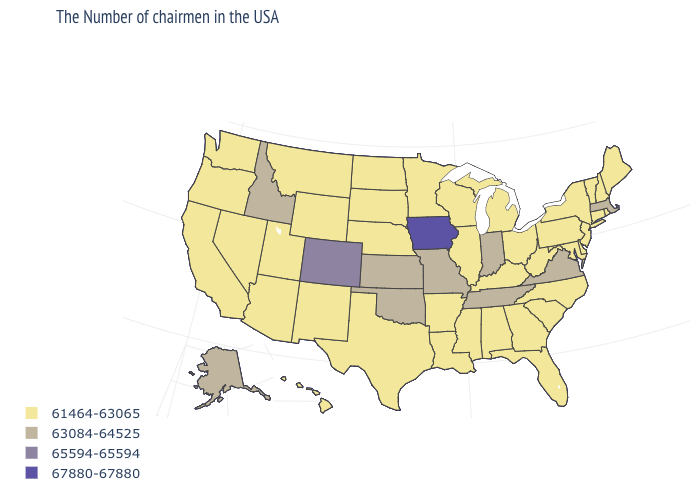What is the value of Massachusetts?
Concise answer only. 63084-64525. What is the value of California?
Write a very short answer. 61464-63065. Name the states that have a value in the range 61464-63065?
Keep it brief. Maine, Rhode Island, New Hampshire, Vermont, Connecticut, New York, New Jersey, Delaware, Maryland, Pennsylvania, North Carolina, South Carolina, West Virginia, Ohio, Florida, Georgia, Michigan, Kentucky, Alabama, Wisconsin, Illinois, Mississippi, Louisiana, Arkansas, Minnesota, Nebraska, Texas, South Dakota, North Dakota, Wyoming, New Mexico, Utah, Montana, Arizona, Nevada, California, Washington, Oregon, Hawaii. What is the value of Georgia?
Short answer required. 61464-63065. What is the highest value in the USA?
Quick response, please. 67880-67880. Name the states that have a value in the range 67880-67880?
Keep it brief. Iowa. What is the lowest value in the MidWest?
Be succinct. 61464-63065. Name the states that have a value in the range 63084-64525?
Write a very short answer. Massachusetts, Virginia, Indiana, Tennessee, Missouri, Kansas, Oklahoma, Idaho, Alaska. Is the legend a continuous bar?
Short answer required. No. Does Alabama have the highest value in the USA?
Short answer required. No. Name the states that have a value in the range 67880-67880?
Short answer required. Iowa. What is the value of Kentucky?
Be succinct. 61464-63065. What is the value of Colorado?
Quick response, please. 65594-65594. 